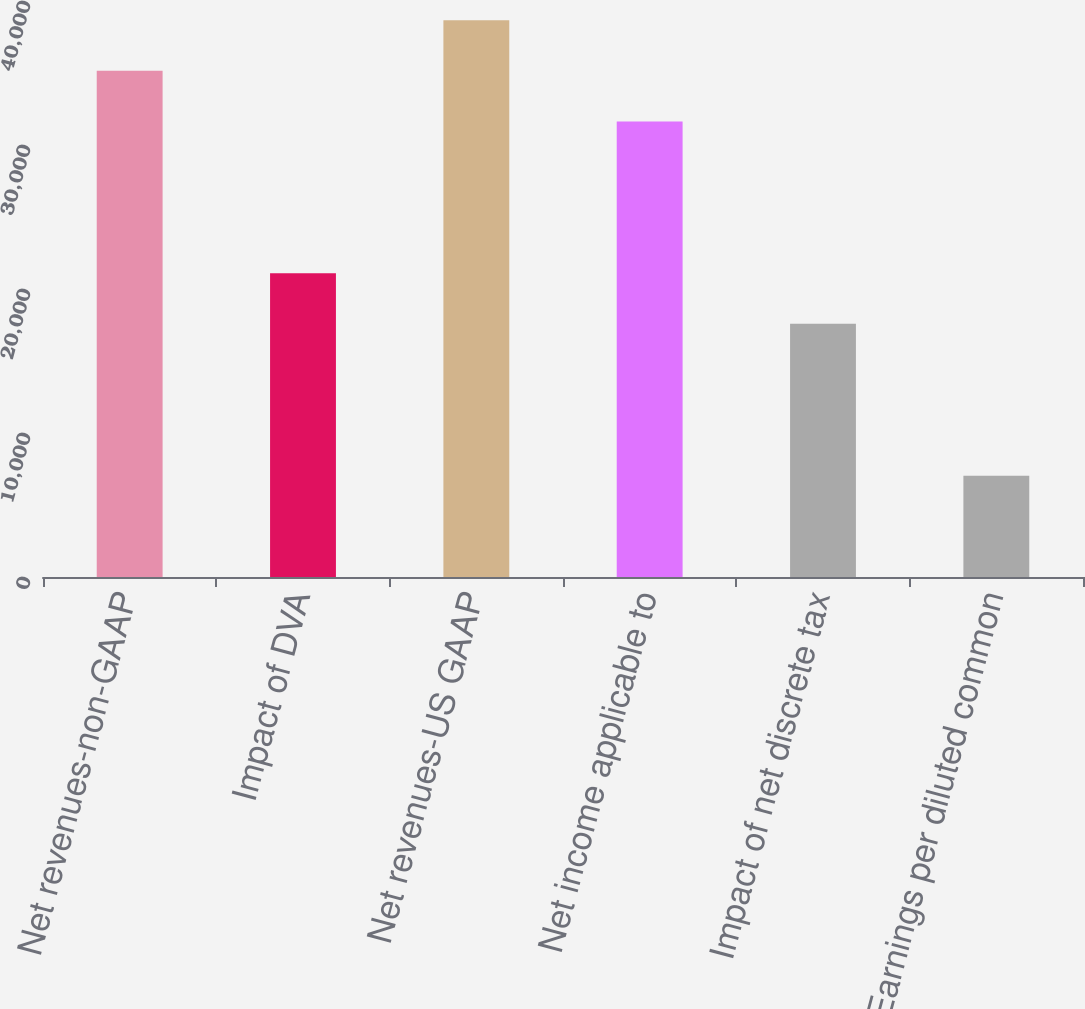<chart> <loc_0><loc_0><loc_500><loc_500><bar_chart><fcel>Net revenues-non-GAAP<fcel>Impact of DVA<fcel>Net revenues-US GAAP<fcel>Net income applicable to<fcel>Impact of net discrete tax<fcel>Earnings per diluted common<nl><fcel>35155<fcel>21094<fcel>38670.3<fcel>31639.8<fcel>17578.7<fcel>7032.93<nl></chart> 